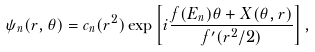Convert formula to latex. <formula><loc_0><loc_0><loc_500><loc_500>\psi _ { n } ( r , \theta ) = c _ { n } ( r ^ { 2 } ) \exp \left [ i \frac { f ( E _ { n } ) \theta + X ( \theta , r ) } { f ^ { \prime } ( r ^ { 2 } / 2 ) } \right ] ,</formula> 